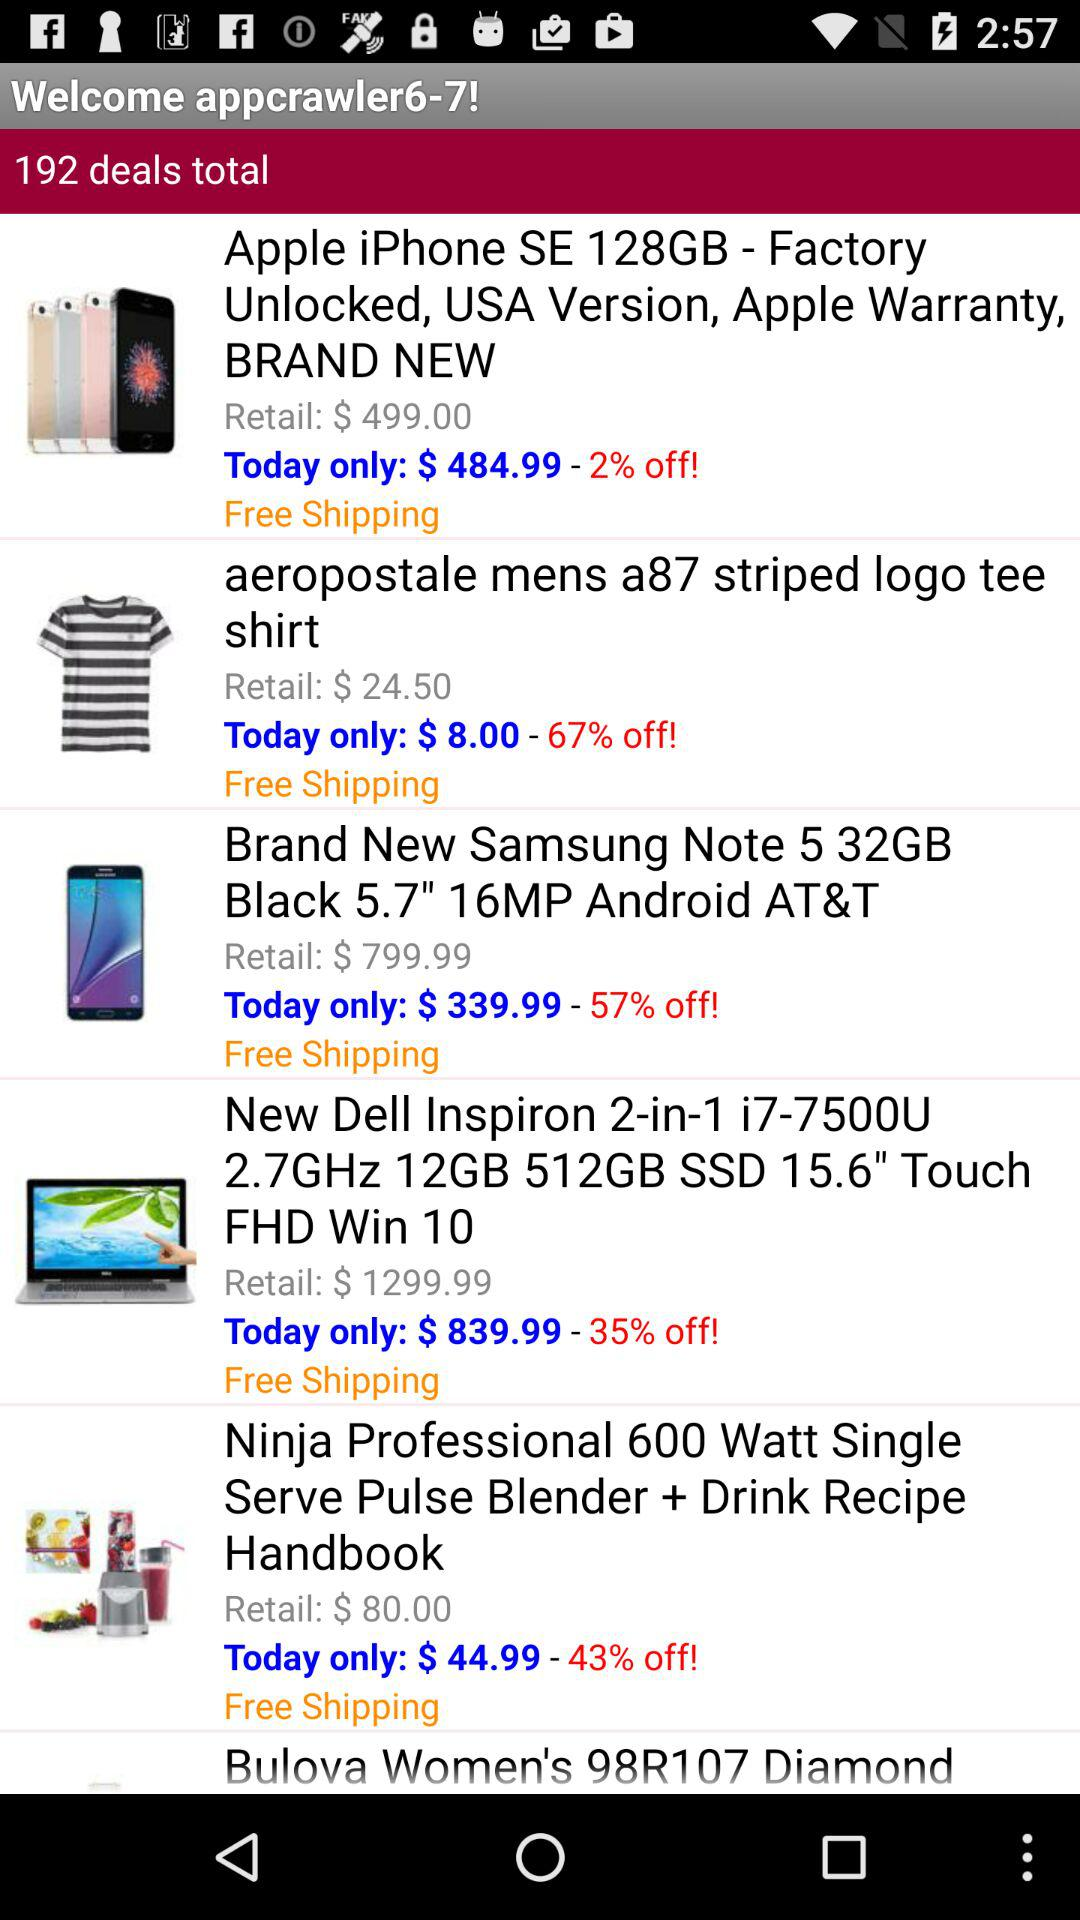What is the application name?
When the provided information is insufficient, respond with <no answer>. <no answer> 